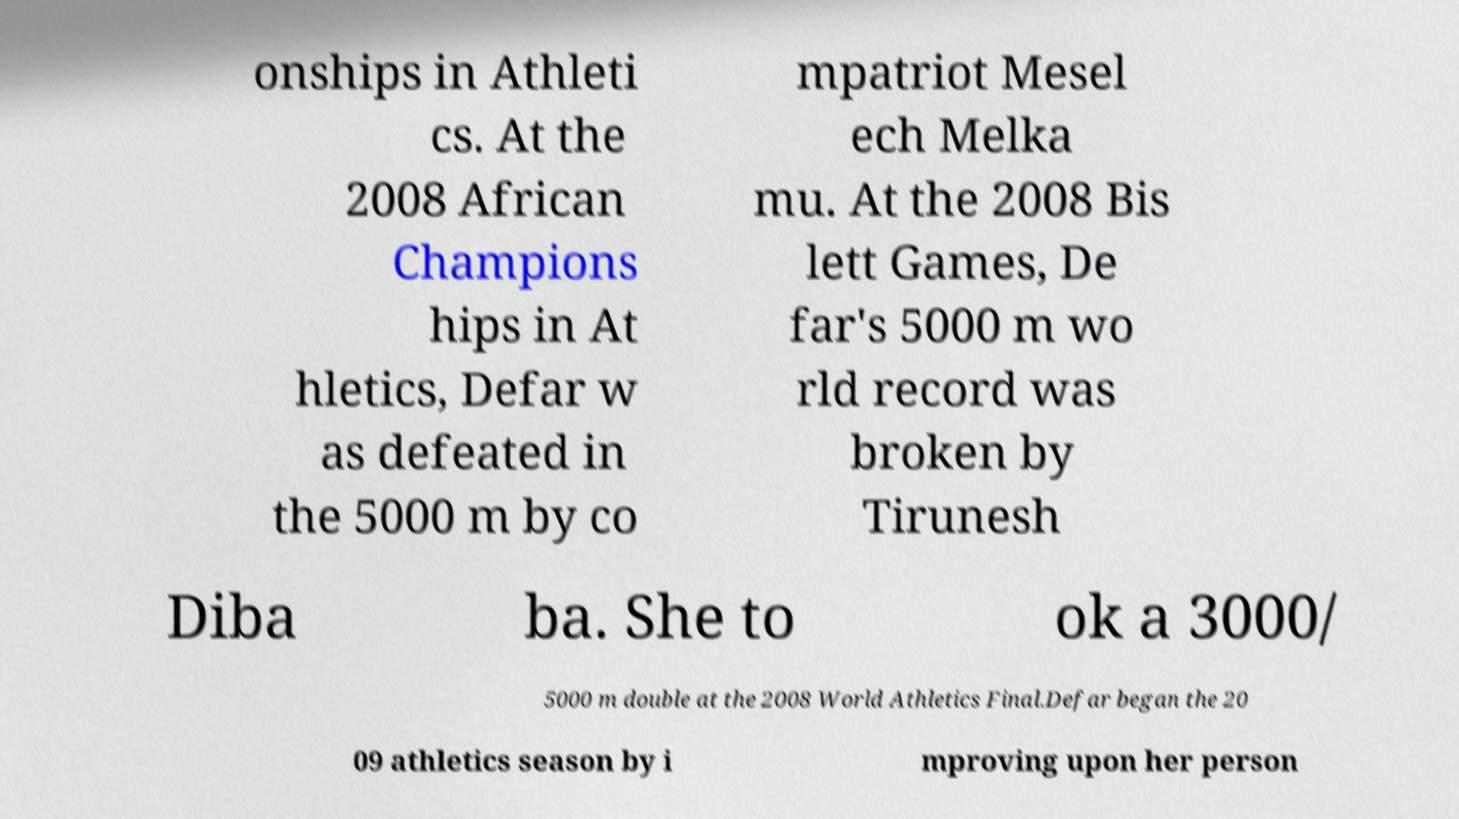Could you assist in decoding the text presented in this image and type it out clearly? onships in Athleti cs. At the 2008 African Champions hips in At hletics, Defar w as defeated in the 5000 m by co mpatriot Mesel ech Melka mu. At the 2008 Bis lett Games, De far's 5000 m wo rld record was broken by Tirunesh Diba ba. She to ok a 3000/ 5000 m double at the 2008 World Athletics Final.Defar began the 20 09 athletics season by i mproving upon her person 